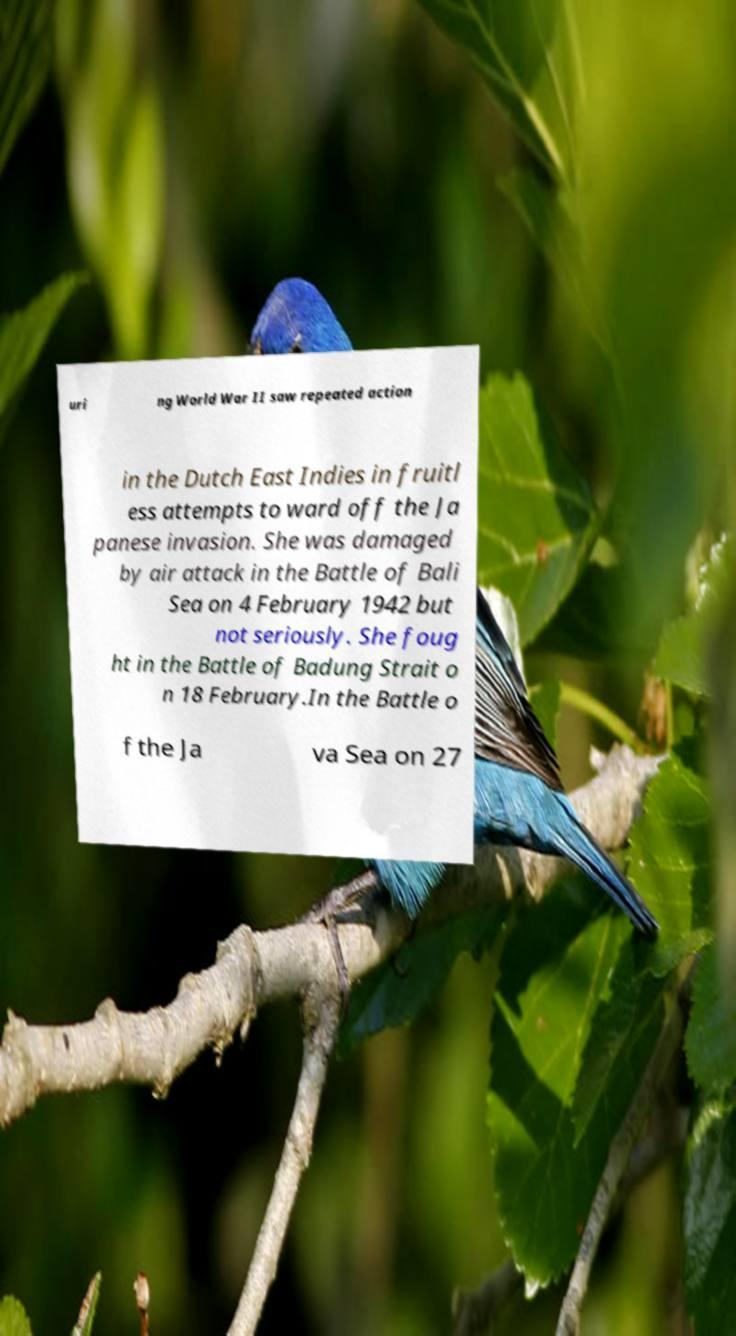There's text embedded in this image that I need extracted. Can you transcribe it verbatim? uri ng World War II saw repeated action in the Dutch East Indies in fruitl ess attempts to ward off the Ja panese invasion. She was damaged by air attack in the Battle of Bali Sea on 4 February 1942 but not seriously. She foug ht in the Battle of Badung Strait o n 18 February.In the Battle o f the Ja va Sea on 27 